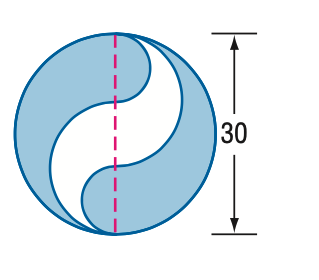Answer the mathemtical geometry problem and directly provide the correct option letter.
Question: Find the area of the shaded region. Round to the nearest tenth.
Choices: A: 392.7 B: 471.2 C: 589.0 D: 785.4 B 